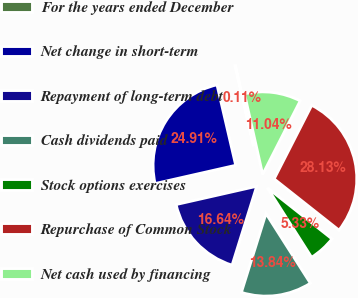Convert chart. <chart><loc_0><loc_0><loc_500><loc_500><pie_chart><fcel>For the years ended December<fcel>Net change in short-term<fcel>Repayment of long-term debt<fcel>Cash dividends paid<fcel>Stock options exercises<fcel>Repurchase of Common Stock<fcel>Net cash used by financing<nl><fcel>0.11%<fcel>24.91%<fcel>16.64%<fcel>13.84%<fcel>5.33%<fcel>28.13%<fcel>11.04%<nl></chart> 